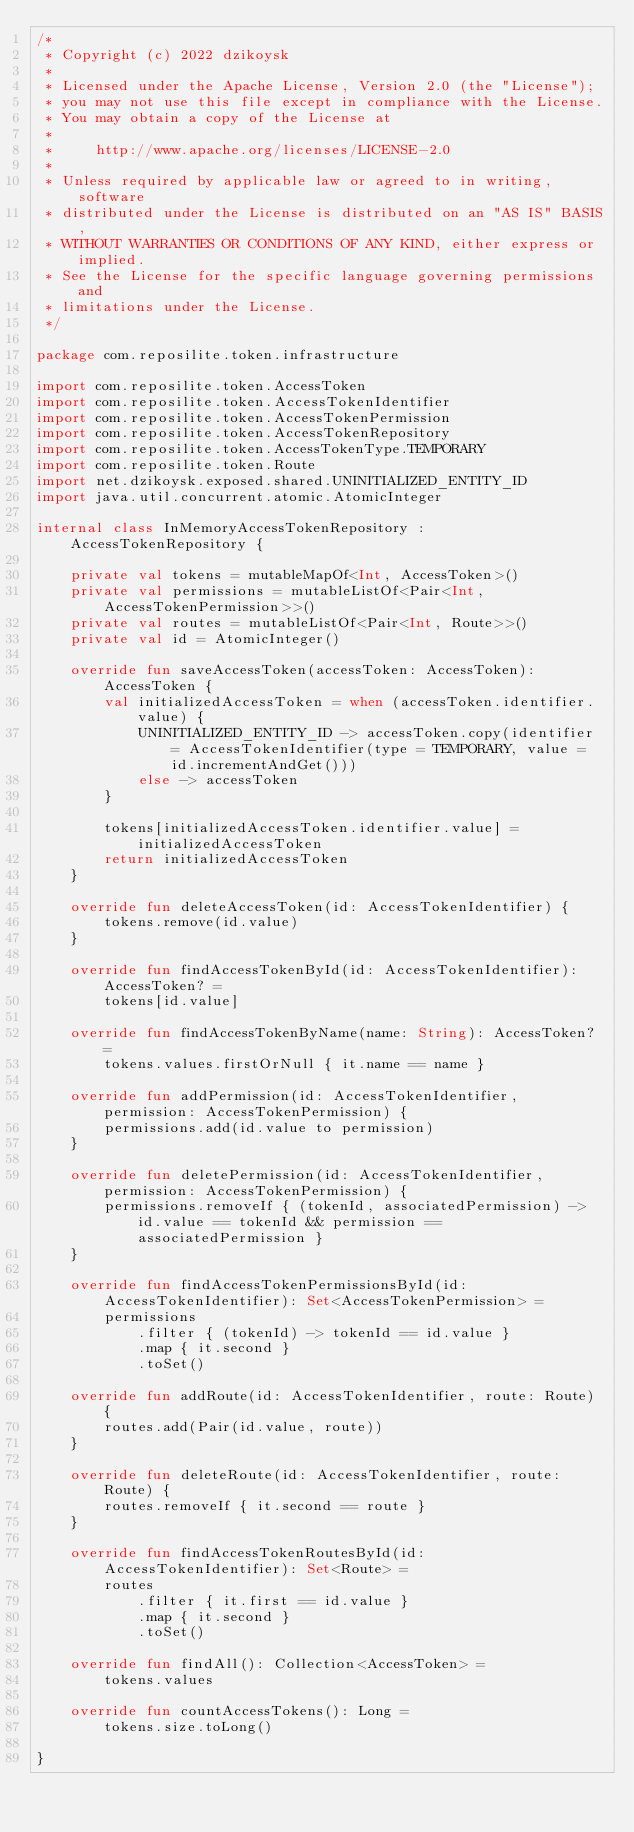<code> <loc_0><loc_0><loc_500><loc_500><_Kotlin_>/*
 * Copyright (c) 2022 dzikoysk
 *
 * Licensed under the Apache License, Version 2.0 (the "License");
 * you may not use this file except in compliance with the License.
 * You may obtain a copy of the License at
 *
 *     http://www.apache.org/licenses/LICENSE-2.0
 *
 * Unless required by applicable law or agreed to in writing, software
 * distributed under the License is distributed on an "AS IS" BASIS,
 * WITHOUT WARRANTIES OR CONDITIONS OF ANY KIND, either express or implied.
 * See the License for the specific language governing permissions and
 * limitations under the License.
 */

package com.reposilite.token.infrastructure

import com.reposilite.token.AccessToken
import com.reposilite.token.AccessTokenIdentifier
import com.reposilite.token.AccessTokenPermission
import com.reposilite.token.AccessTokenRepository
import com.reposilite.token.AccessTokenType.TEMPORARY
import com.reposilite.token.Route
import net.dzikoysk.exposed.shared.UNINITIALIZED_ENTITY_ID
import java.util.concurrent.atomic.AtomicInteger

internal class InMemoryAccessTokenRepository : AccessTokenRepository {

    private val tokens = mutableMapOf<Int, AccessToken>()
    private val permissions = mutableListOf<Pair<Int, AccessTokenPermission>>()
    private val routes = mutableListOf<Pair<Int, Route>>()
    private val id = AtomicInteger()

    override fun saveAccessToken(accessToken: AccessToken): AccessToken {
        val initializedAccessToken = when (accessToken.identifier.value) {
            UNINITIALIZED_ENTITY_ID -> accessToken.copy(identifier = AccessTokenIdentifier(type = TEMPORARY, value = id.incrementAndGet()))
            else -> accessToken
        }

        tokens[initializedAccessToken.identifier.value] = initializedAccessToken
        return initializedAccessToken
    }

    override fun deleteAccessToken(id: AccessTokenIdentifier) {
        tokens.remove(id.value)
    }

    override fun findAccessTokenById(id: AccessTokenIdentifier): AccessToken? =
        tokens[id.value]

    override fun findAccessTokenByName(name: String): AccessToken? =
        tokens.values.firstOrNull { it.name == name }

    override fun addPermission(id: AccessTokenIdentifier, permission: AccessTokenPermission) {
        permissions.add(id.value to permission)
    }

    override fun deletePermission(id: AccessTokenIdentifier, permission: AccessTokenPermission) {
        permissions.removeIf { (tokenId, associatedPermission) -> id.value == tokenId && permission == associatedPermission }
    }

    override fun findAccessTokenPermissionsById(id: AccessTokenIdentifier): Set<AccessTokenPermission> =
        permissions
            .filter { (tokenId) -> tokenId == id.value }
            .map { it.second }
            .toSet()

    override fun addRoute(id: AccessTokenIdentifier, route: Route) {
        routes.add(Pair(id.value, route))
    }

    override fun deleteRoute(id: AccessTokenIdentifier, route: Route) {
        routes.removeIf { it.second == route }
    }

    override fun findAccessTokenRoutesById(id: AccessTokenIdentifier): Set<Route> =
        routes
            .filter { it.first == id.value }
            .map { it.second }
            .toSet()

    override fun findAll(): Collection<AccessToken> =
        tokens.values

    override fun countAccessTokens(): Long =
        tokens.size.toLong()

}
</code> 